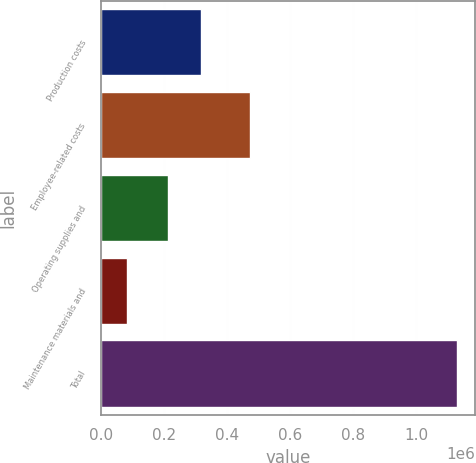Convert chart. <chart><loc_0><loc_0><loc_500><loc_500><bar_chart><fcel>Production costs<fcel>Employee-related costs<fcel>Operating supplies and<fcel>Maintenance materials and<fcel>Total<nl><fcel>315839<fcel>472075<fcel>210947<fcel>81062<fcel>1.12999e+06<nl></chart> 